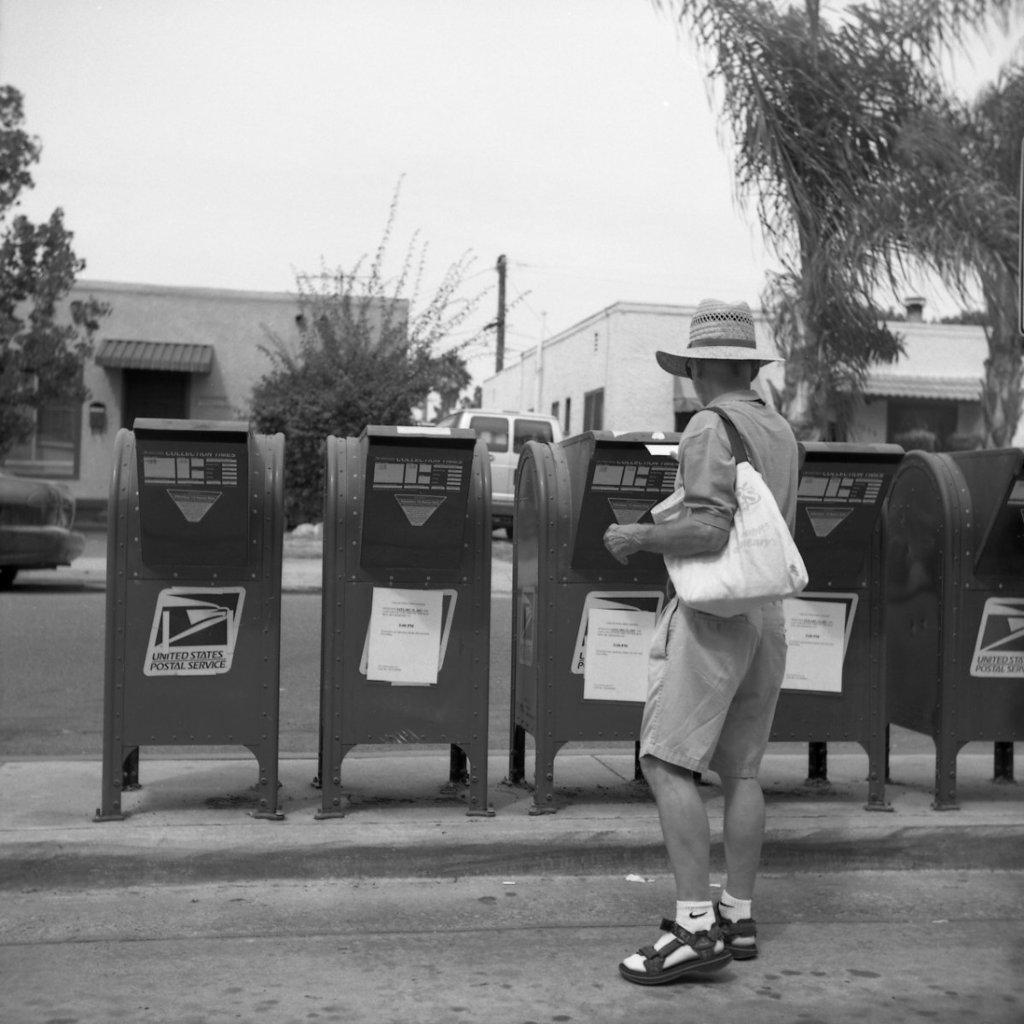Provide a one-sentence caption for the provided image. Man standing in front of a mailbox which says United States Postal Service. 